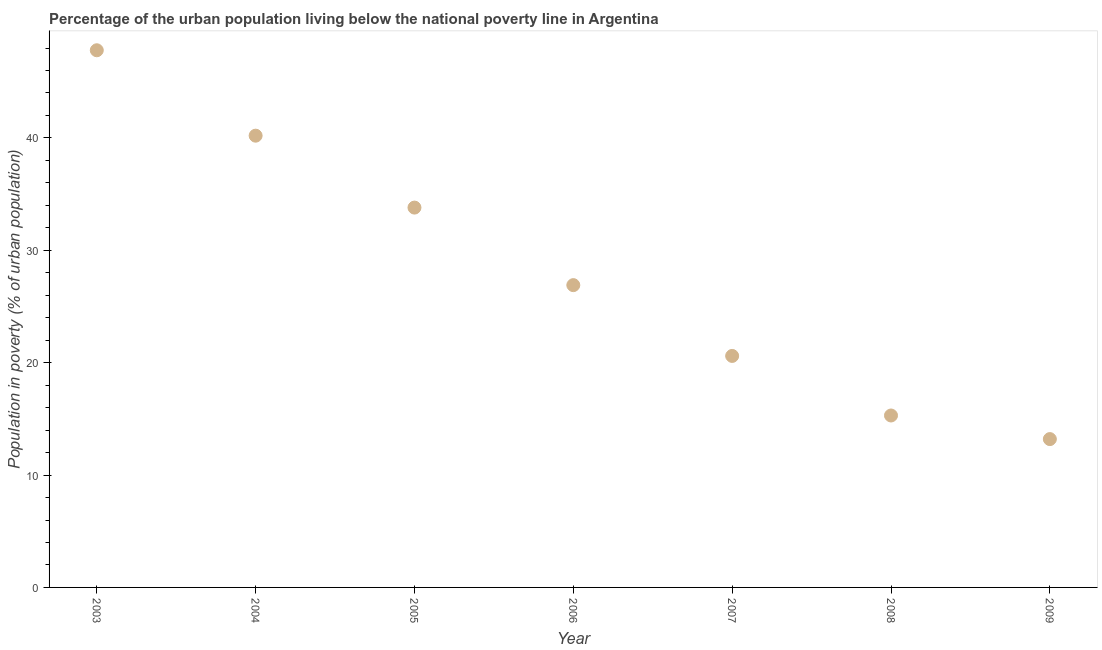What is the percentage of urban population living below poverty line in 2008?
Give a very brief answer. 15.3. Across all years, what is the maximum percentage of urban population living below poverty line?
Make the answer very short. 47.8. In which year was the percentage of urban population living below poverty line maximum?
Give a very brief answer. 2003. In which year was the percentage of urban population living below poverty line minimum?
Make the answer very short. 2009. What is the sum of the percentage of urban population living below poverty line?
Give a very brief answer. 197.8. What is the difference between the percentage of urban population living below poverty line in 2003 and 2008?
Your answer should be compact. 32.5. What is the average percentage of urban population living below poverty line per year?
Your answer should be compact. 28.26. What is the median percentage of urban population living below poverty line?
Provide a succinct answer. 26.9. What is the ratio of the percentage of urban population living below poverty line in 2003 to that in 2004?
Keep it short and to the point. 1.19. Is the percentage of urban population living below poverty line in 2004 less than that in 2009?
Provide a succinct answer. No. Is the difference between the percentage of urban population living below poverty line in 2004 and 2007 greater than the difference between any two years?
Your answer should be compact. No. What is the difference between the highest and the second highest percentage of urban population living below poverty line?
Keep it short and to the point. 7.6. Is the sum of the percentage of urban population living below poverty line in 2004 and 2007 greater than the maximum percentage of urban population living below poverty line across all years?
Your answer should be very brief. Yes. What is the difference between the highest and the lowest percentage of urban population living below poverty line?
Provide a succinct answer. 34.6. In how many years, is the percentage of urban population living below poverty line greater than the average percentage of urban population living below poverty line taken over all years?
Give a very brief answer. 3. Does the graph contain any zero values?
Your answer should be very brief. No. Does the graph contain grids?
Ensure brevity in your answer.  No. What is the title of the graph?
Your response must be concise. Percentage of the urban population living below the national poverty line in Argentina. What is the label or title of the Y-axis?
Your answer should be compact. Population in poverty (% of urban population). What is the Population in poverty (% of urban population) in 2003?
Provide a short and direct response. 47.8. What is the Population in poverty (% of urban population) in 2004?
Give a very brief answer. 40.2. What is the Population in poverty (% of urban population) in 2005?
Give a very brief answer. 33.8. What is the Population in poverty (% of urban population) in 2006?
Your response must be concise. 26.9. What is the Population in poverty (% of urban population) in 2007?
Ensure brevity in your answer.  20.6. What is the Population in poverty (% of urban population) in 2009?
Make the answer very short. 13.2. What is the difference between the Population in poverty (% of urban population) in 2003 and 2005?
Offer a very short reply. 14. What is the difference between the Population in poverty (% of urban population) in 2003 and 2006?
Ensure brevity in your answer.  20.9. What is the difference between the Population in poverty (% of urban population) in 2003 and 2007?
Make the answer very short. 27.2. What is the difference between the Population in poverty (% of urban population) in 2003 and 2008?
Offer a very short reply. 32.5. What is the difference between the Population in poverty (% of urban population) in 2003 and 2009?
Give a very brief answer. 34.6. What is the difference between the Population in poverty (% of urban population) in 2004 and 2005?
Provide a short and direct response. 6.4. What is the difference between the Population in poverty (% of urban population) in 2004 and 2007?
Provide a short and direct response. 19.6. What is the difference between the Population in poverty (% of urban population) in 2004 and 2008?
Give a very brief answer. 24.9. What is the difference between the Population in poverty (% of urban population) in 2005 and 2007?
Keep it short and to the point. 13.2. What is the difference between the Population in poverty (% of urban population) in 2005 and 2009?
Make the answer very short. 20.6. What is the difference between the Population in poverty (% of urban population) in 2007 and 2009?
Provide a succinct answer. 7.4. What is the difference between the Population in poverty (% of urban population) in 2008 and 2009?
Give a very brief answer. 2.1. What is the ratio of the Population in poverty (% of urban population) in 2003 to that in 2004?
Ensure brevity in your answer.  1.19. What is the ratio of the Population in poverty (% of urban population) in 2003 to that in 2005?
Your response must be concise. 1.41. What is the ratio of the Population in poverty (% of urban population) in 2003 to that in 2006?
Your answer should be very brief. 1.78. What is the ratio of the Population in poverty (% of urban population) in 2003 to that in 2007?
Your response must be concise. 2.32. What is the ratio of the Population in poverty (% of urban population) in 2003 to that in 2008?
Offer a terse response. 3.12. What is the ratio of the Population in poverty (% of urban population) in 2003 to that in 2009?
Give a very brief answer. 3.62. What is the ratio of the Population in poverty (% of urban population) in 2004 to that in 2005?
Your response must be concise. 1.19. What is the ratio of the Population in poverty (% of urban population) in 2004 to that in 2006?
Your answer should be very brief. 1.49. What is the ratio of the Population in poverty (% of urban population) in 2004 to that in 2007?
Give a very brief answer. 1.95. What is the ratio of the Population in poverty (% of urban population) in 2004 to that in 2008?
Give a very brief answer. 2.63. What is the ratio of the Population in poverty (% of urban population) in 2004 to that in 2009?
Provide a short and direct response. 3.04. What is the ratio of the Population in poverty (% of urban population) in 2005 to that in 2006?
Make the answer very short. 1.26. What is the ratio of the Population in poverty (% of urban population) in 2005 to that in 2007?
Offer a terse response. 1.64. What is the ratio of the Population in poverty (% of urban population) in 2005 to that in 2008?
Make the answer very short. 2.21. What is the ratio of the Population in poverty (% of urban population) in 2005 to that in 2009?
Offer a very short reply. 2.56. What is the ratio of the Population in poverty (% of urban population) in 2006 to that in 2007?
Provide a succinct answer. 1.31. What is the ratio of the Population in poverty (% of urban population) in 2006 to that in 2008?
Your answer should be very brief. 1.76. What is the ratio of the Population in poverty (% of urban population) in 2006 to that in 2009?
Your answer should be very brief. 2.04. What is the ratio of the Population in poverty (% of urban population) in 2007 to that in 2008?
Your answer should be compact. 1.35. What is the ratio of the Population in poverty (% of urban population) in 2007 to that in 2009?
Make the answer very short. 1.56. What is the ratio of the Population in poverty (% of urban population) in 2008 to that in 2009?
Provide a short and direct response. 1.16. 